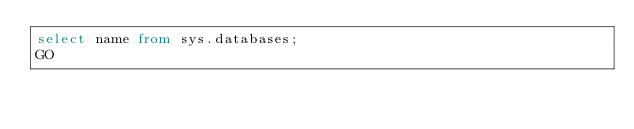<code> <loc_0><loc_0><loc_500><loc_500><_SQL_>select name from sys.databases;
GO</code> 